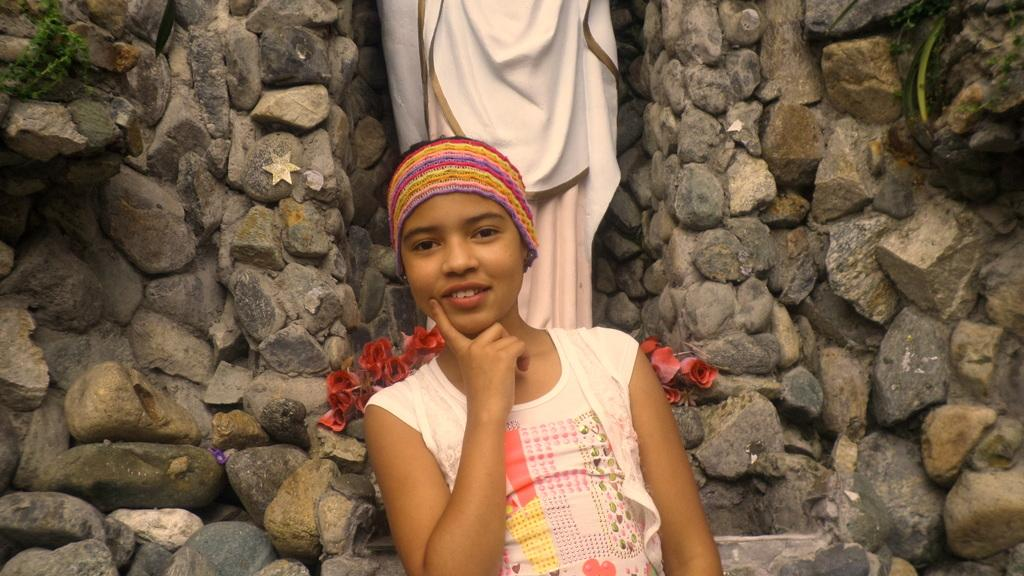What is the main subject of the image? There is a person standing near a wall in the image. What can be seen in the background of the image? There are flowers and a statue visible in the background of the image. How does the person in the image address the issue of pollution? The image does not show any indication of pollution or the person addressing it. 